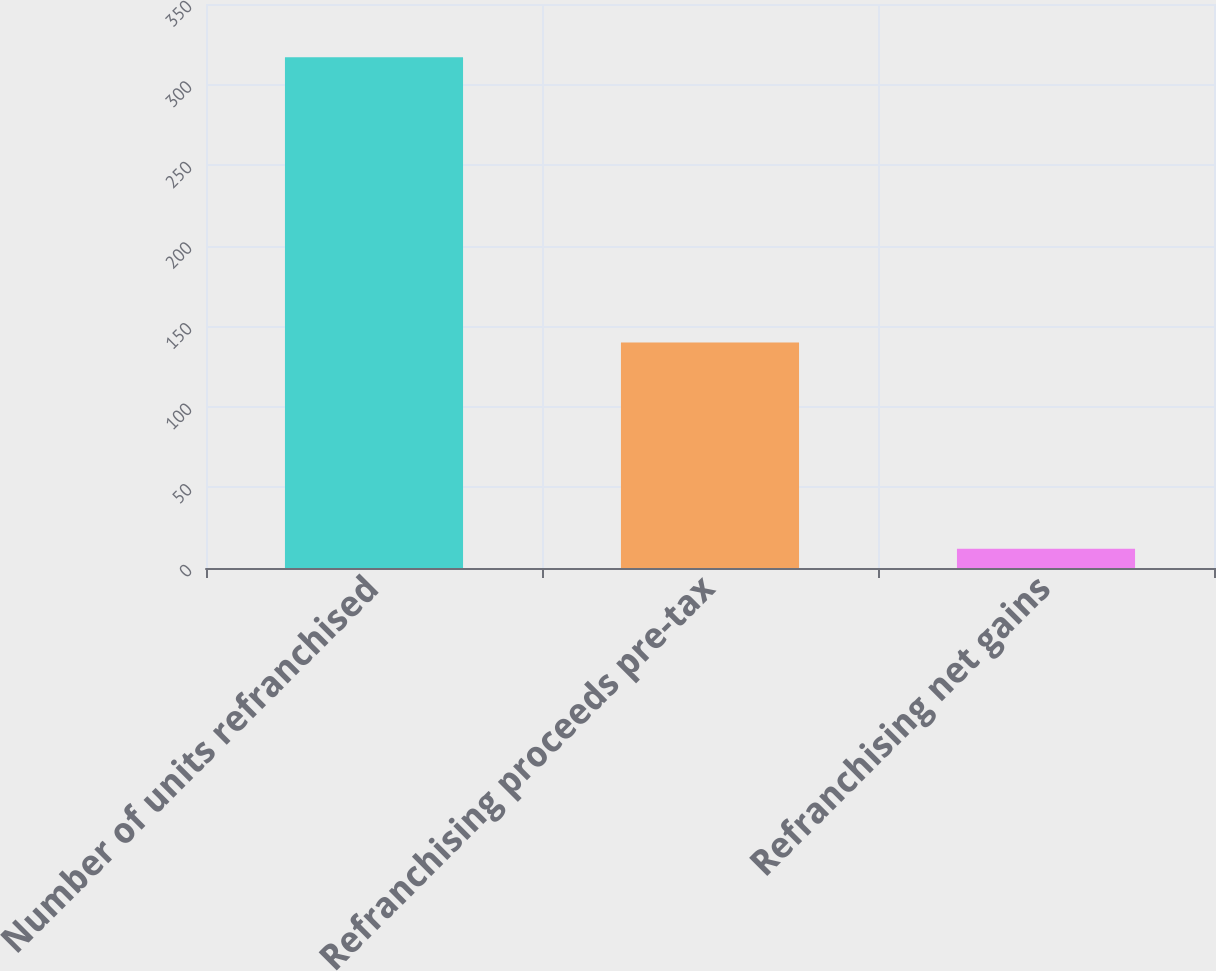<chart> <loc_0><loc_0><loc_500><loc_500><bar_chart><fcel>Number of units refranchised<fcel>Refranchising proceeds pre-tax<fcel>Refranchising net gains<nl><fcel>317<fcel>140<fcel>12<nl></chart> 